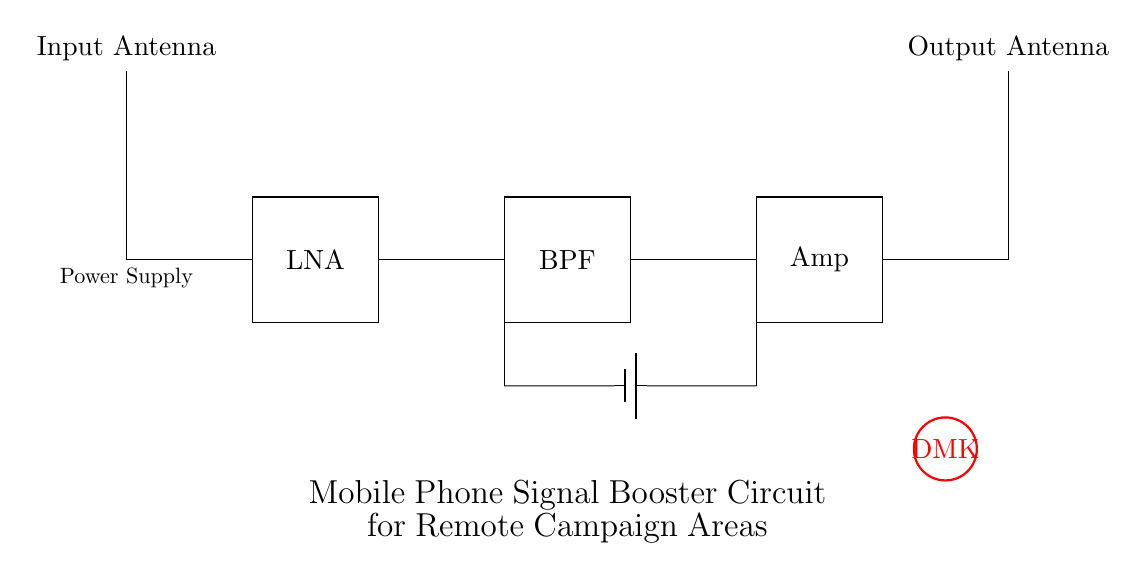What is the first component of the circuit? The first component in the circuit diagram is the input antenna, which is depicted at the top left. It receives the incoming mobile signal before amplification.
Answer: input antenna What does LNA stand for? LNA stands for Low Noise Amplifier, which is labeled in the circuit. Its function is to amplify weak signals while adding minimal noise.
Answer: Low Noise Amplifier How many antennas are in the circuit? There are two antennas in the circuit: an input antenna and an output antenna, both shown at the top corners of the diagram.
Answer: two What is the function of the Band Pass Filter? The Band Pass Filter (BPF) allows only specific frequency ranges to pass through while blocking others, facilitating improved signal quality after amplification.
Answer: specific frequency ranges Which component requires a power supply? The components that require a power supply are the Low Noise Amplifier, Band Pass Filter, and the Signal Amplifier, all of which are powered through the indicated battery.
Answer: Low Noise Amplifier, Band Pass Filter, Signal Amplifier What does the 'DMK' logo represent in this circuit? The 'DMK' logo in the circuit represents Dravida Munnetra Kazhagam, indicating political support and affiliation with the local campaign context of the circuit.
Answer: Dravida Munnetra Kazhagam 